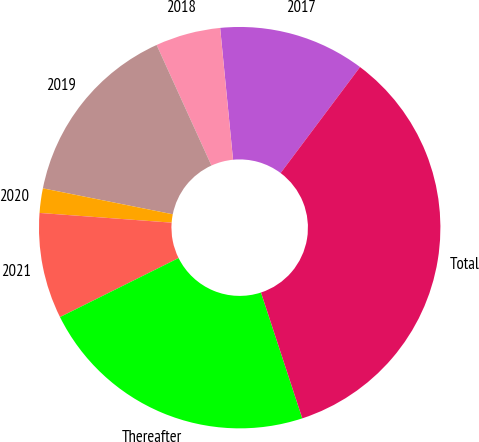<chart> <loc_0><loc_0><loc_500><loc_500><pie_chart><fcel>2017<fcel>2018<fcel>2019<fcel>2020<fcel>2021<fcel>Thereafter<fcel>Total<nl><fcel>11.79%<fcel>5.24%<fcel>15.07%<fcel>1.97%<fcel>8.52%<fcel>22.7%<fcel>34.72%<nl></chart> 